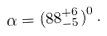Convert formula to latex. <formula><loc_0><loc_0><loc_500><loc_500>\alpha = ( 8 8 ^ { + 6 } _ { - 5 } ) ^ { 0 } \, .</formula> 